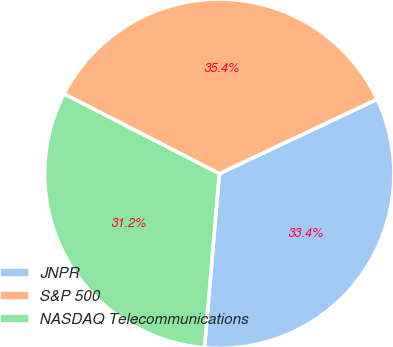<chart> <loc_0><loc_0><loc_500><loc_500><pie_chart><fcel>JNPR<fcel>S&P 500<fcel>NASDAQ Telecommunications<nl><fcel>33.36%<fcel>35.42%<fcel>31.21%<nl></chart> 